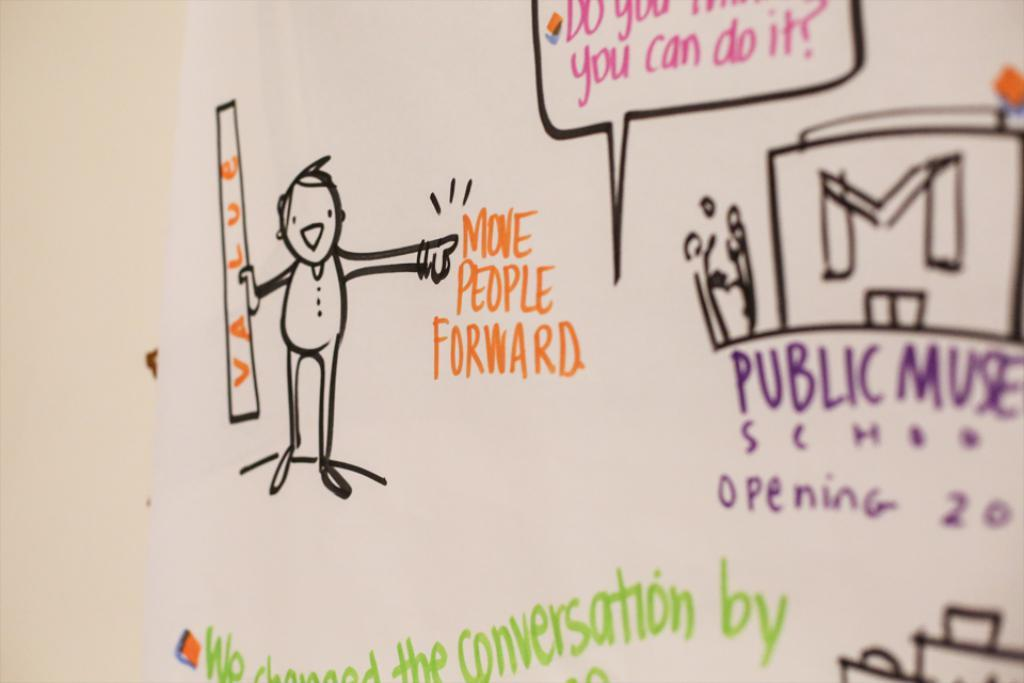What is the main subject of the image? The main subject of the image is a drawing. What else is present in the image besides the drawing? There is text and a person in the image. How many spiders are crawling on the person in the image? There are no spiders present in the image; it features a drawing, text, and a person. 